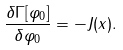<formula> <loc_0><loc_0><loc_500><loc_500>\frac { \delta \Gamma [ \varphi _ { 0 } ] } { \delta \varphi _ { 0 } } = - J ( x ) .</formula> 